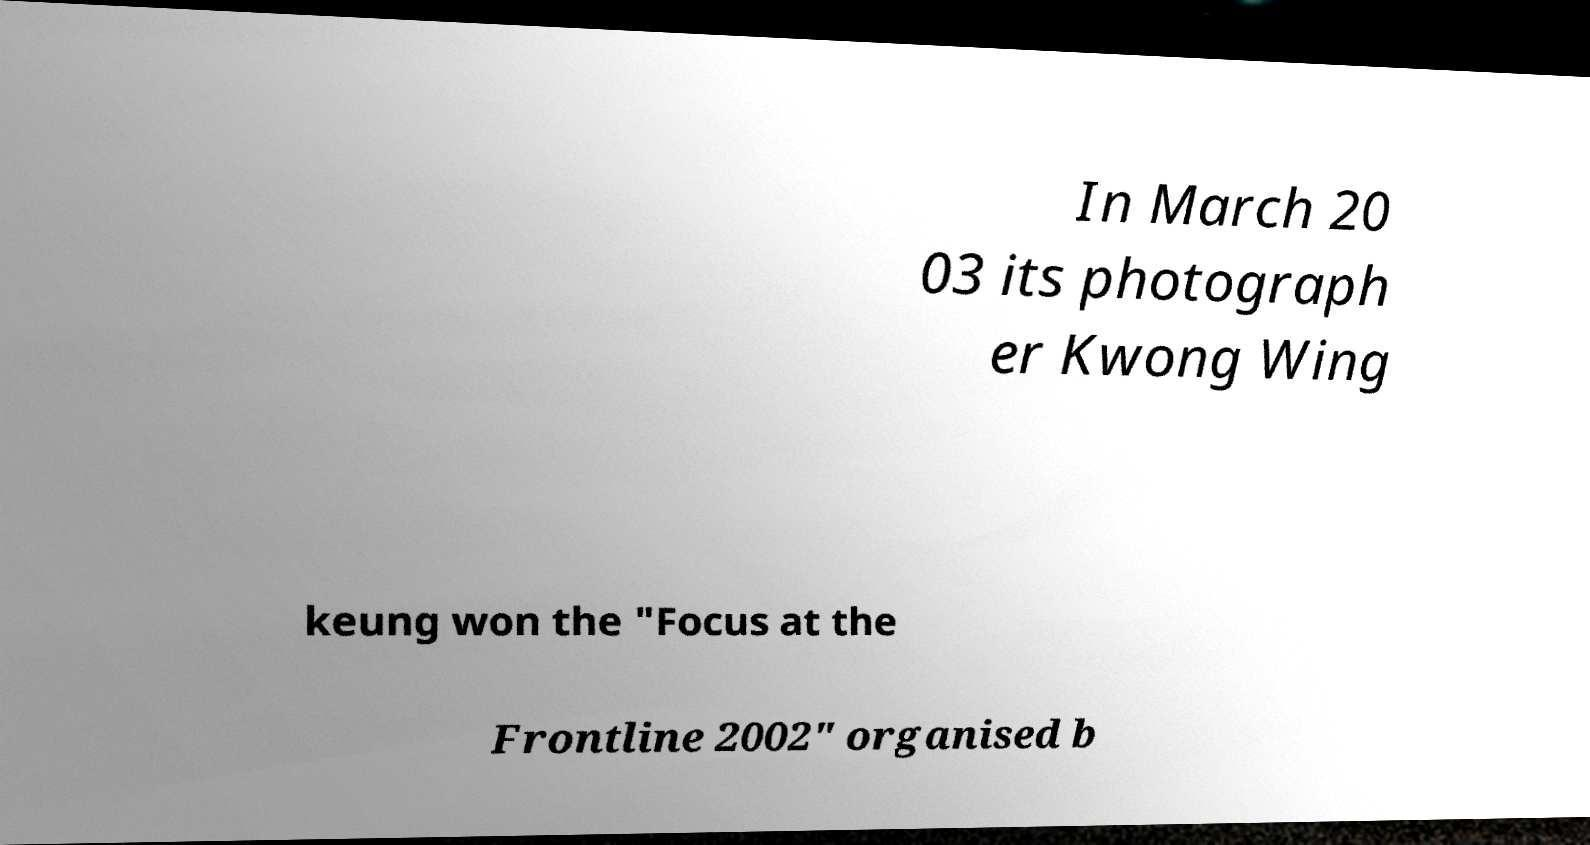There's text embedded in this image that I need extracted. Can you transcribe it verbatim? In March 20 03 its photograph er Kwong Wing keung won the "Focus at the Frontline 2002" organised b 